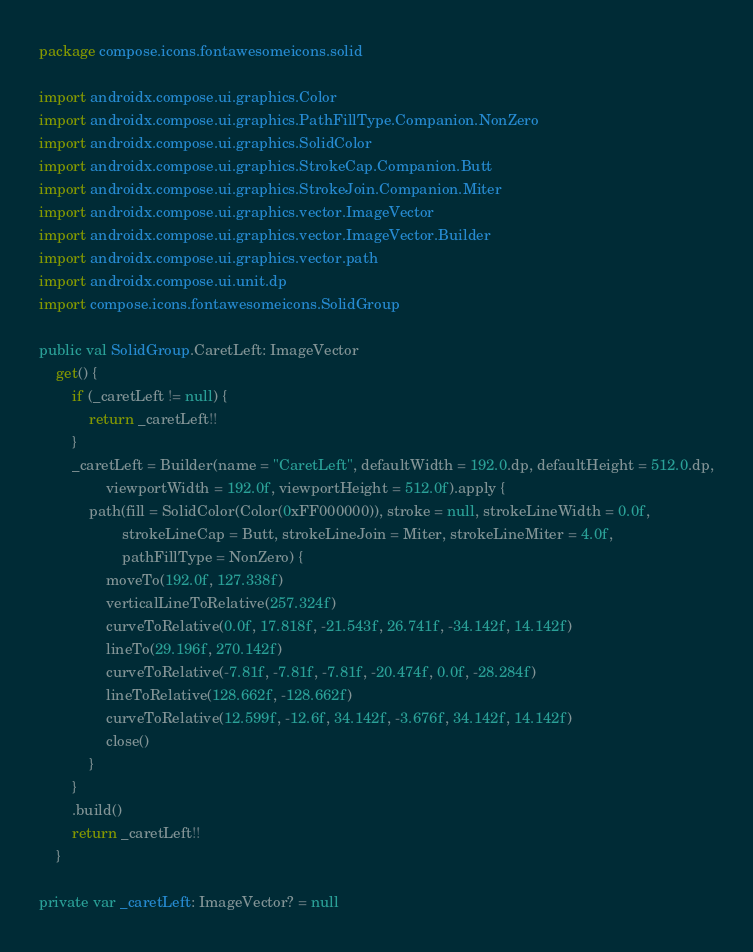<code> <loc_0><loc_0><loc_500><loc_500><_Kotlin_>package compose.icons.fontawesomeicons.solid

import androidx.compose.ui.graphics.Color
import androidx.compose.ui.graphics.PathFillType.Companion.NonZero
import androidx.compose.ui.graphics.SolidColor
import androidx.compose.ui.graphics.StrokeCap.Companion.Butt
import androidx.compose.ui.graphics.StrokeJoin.Companion.Miter
import androidx.compose.ui.graphics.vector.ImageVector
import androidx.compose.ui.graphics.vector.ImageVector.Builder
import androidx.compose.ui.graphics.vector.path
import androidx.compose.ui.unit.dp
import compose.icons.fontawesomeicons.SolidGroup

public val SolidGroup.CaretLeft: ImageVector
    get() {
        if (_caretLeft != null) {
            return _caretLeft!!
        }
        _caretLeft = Builder(name = "CaretLeft", defaultWidth = 192.0.dp, defaultHeight = 512.0.dp,
                viewportWidth = 192.0f, viewportHeight = 512.0f).apply {
            path(fill = SolidColor(Color(0xFF000000)), stroke = null, strokeLineWidth = 0.0f,
                    strokeLineCap = Butt, strokeLineJoin = Miter, strokeLineMiter = 4.0f,
                    pathFillType = NonZero) {
                moveTo(192.0f, 127.338f)
                verticalLineToRelative(257.324f)
                curveToRelative(0.0f, 17.818f, -21.543f, 26.741f, -34.142f, 14.142f)
                lineTo(29.196f, 270.142f)
                curveToRelative(-7.81f, -7.81f, -7.81f, -20.474f, 0.0f, -28.284f)
                lineToRelative(128.662f, -128.662f)
                curveToRelative(12.599f, -12.6f, 34.142f, -3.676f, 34.142f, 14.142f)
                close()
            }
        }
        .build()
        return _caretLeft!!
    }

private var _caretLeft: ImageVector? = null
</code> 